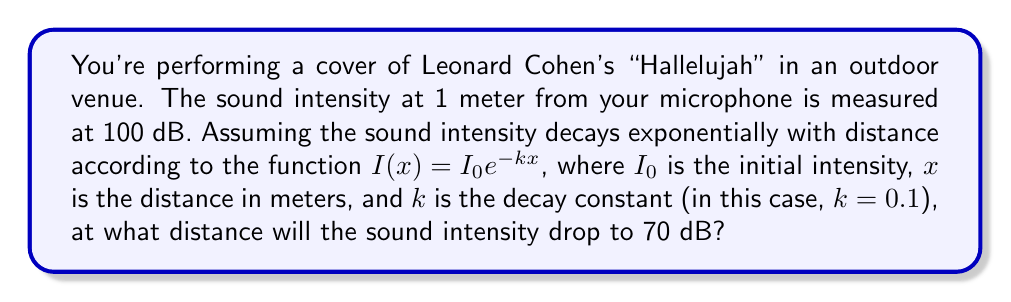Can you answer this question? To solve this problem, we'll follow these steps:

1) First, we need to convert the decibel (dB) values to intensity values. The relationship between decibel and intensity is given by:

   $$ dB = 10 \log_{10}\left(\frac{I}{I_{ref}}\right) $$

   where $I_{ref}$ is a reference intensity (typically $10^{-12}$ W/m²).

2) For the initial intensity (100 dB):
   $$ 100 = 10 \log_{10}\left(\frac{I_0}{10^{-12}}\right) $$
   $$ 10 = \log_{10}\left(\frac{I_0}{10^{-12}}\right) $$
   $$ I_0 = 10^{-2} \text{ W/m²} $$

3) For the final intensity (70 dB):
   $$ 70 = 10 \log_{10}\left(\frac{I}{10^{-12}}\right) $$
   $$ 7 = \log_{10}\left(\frac{I}{10^{-12}}\right) $$
   $$ I = 10^{-5} \text{ W/m²} $$

4) Now we can use the exponential decay function:
   $$ I(x) = I_0 e^{-kx} $$
   $$ 10^{-5} = 10^{-2} e^{-0.1x} $$

5) Solving for x:
   $$ 10^{-3} = e^{-0.1x} $$
   $$ \ln(10^{-3}) = -0.1x $$
   $$ -6.908 = -0.1x $$
   $$ x = 69.08 \text{ meters} $$

Therefore, the sound intensity will drop to 70 dB at approximately 69.08 meters from the microphone.
Answer: 69.08 meters 